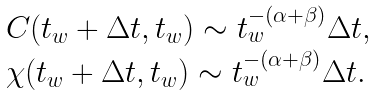Convert formula to latex. <formula><loc_0><loc_0><loc_500><loc_500>\begin{array} { l l } C ( t _ { w } + \Delta t , t _ { w } ) \sim t _ { w } ^ { - ( \alpha + \beta ) } \Delta t , \\ \chi ( t _ { w } + \Delta t , t _ { w } ) \sim t _ { w } ^ { - ( \alpha + \beta ) } \Delta t . \end{array}</formula> 